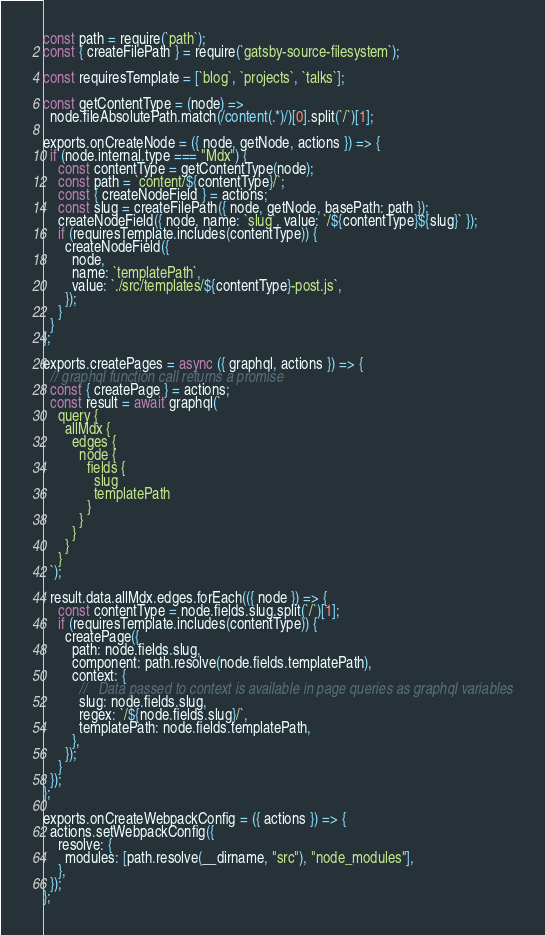<code> <loc_0><loc_0><loc_500><loc_500><_JavaScript_>const path = require(`path`);
const { createFilePath } = require(`gatsby-source-filesystem`);

const requiresTemplate = [`blog`, `projects`, `talks`];

const getContentType = (node) =>
  node.fileAbsolutePath.match(/content(.*)/)[0].split(`/`)[1];

exports.onCreateNode = ({ node, getNode, actions }) => {
  if (node.internal.type === "Mdx") {
    const contentType = getContentType(node);
    const path = `content/${contentType}/`;
    const { createNodeField } = actions;
    const slug = createFilePath({ node, getNode, basePath: path });
    createNodeField({ node, name: `slug`, value: `/${contentType}${slug}` });
    if (requiresTemplate.includes(contentType)) {
      createNodeField({
        node,
        name: `templatePath`,
        value: `./src/templates/${contentType}-post.js`,
      });
    }
  }
};

exports.createPages = async ({ graphql, actions }) => {
  // graphql function call returns a promise
  const { createPage } = actions;
  const result = await graphql(`
    query {
      allMdx {
        edges {
          node {
            fields {
              slug
              templatePath
            }
          }
        }
      }
    }
  `);

  result.data.allMdx.edges.forEach(({ node }) => {
    const contentType = node.fields.slug.split(`/`)[1];
    if (requiresTemplate.includes(contentType)) {
      createPage({
        path: node.fields.slug,
        component: path.resolve(node.fields.templatePath),
        context: {
          //   Data passed to context is available in page queries as graphql variables
          slug: node.fields.slug,
          regex: `/${node.fields.slug}/`,
          templatePath: node.fields.templatePath,
        },
      });
    }
  });
};

exports.onCreateWebpackConfig = ({ actions }) => {
  actions.setWebpackConfig({
    resolve: {
      modules: [path.resolve(__dirname, "src"), "node_modules"],
    },
  });
};
</code> 